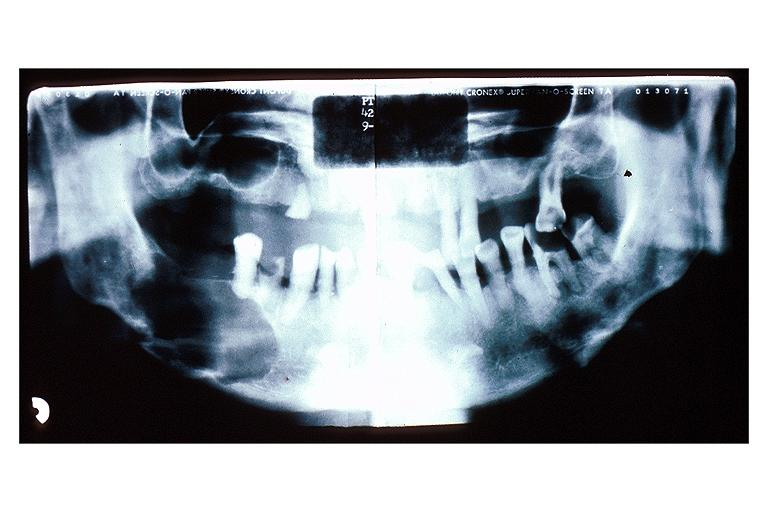does this image show multiple myeloma?
Answer the question using a single word or phrase. Yes 